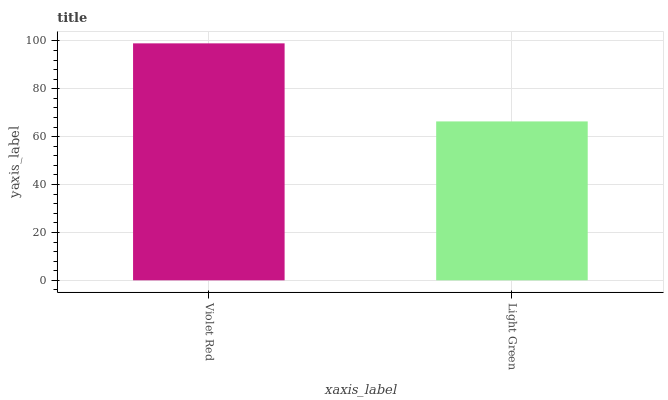Is Light Green the minimum?
Answer yes or no. Yes. Is Violet Red the maximum?
Answer yes or no. Yes. Is Light Green the maximum?
Answer yes or no. No. Is Violet Red greater than Light Green?
Answer yes or no. Yes. Is Light Green less than Violet Red?
Answer yes or no. Yes. Is Light Green greater than Violet Red?
Answer yes or no. No. Is Violet Red less than Light Green?
Answer yes or no. No. Is Violet Red the high median?
Answer yes or no. Yes. Is Light Green the low median?
Answer yes or no. Yes. Is Light Green the high median?
Answer yes or no. No. Is Violet Red the low median?
Answer yes or no. No. 